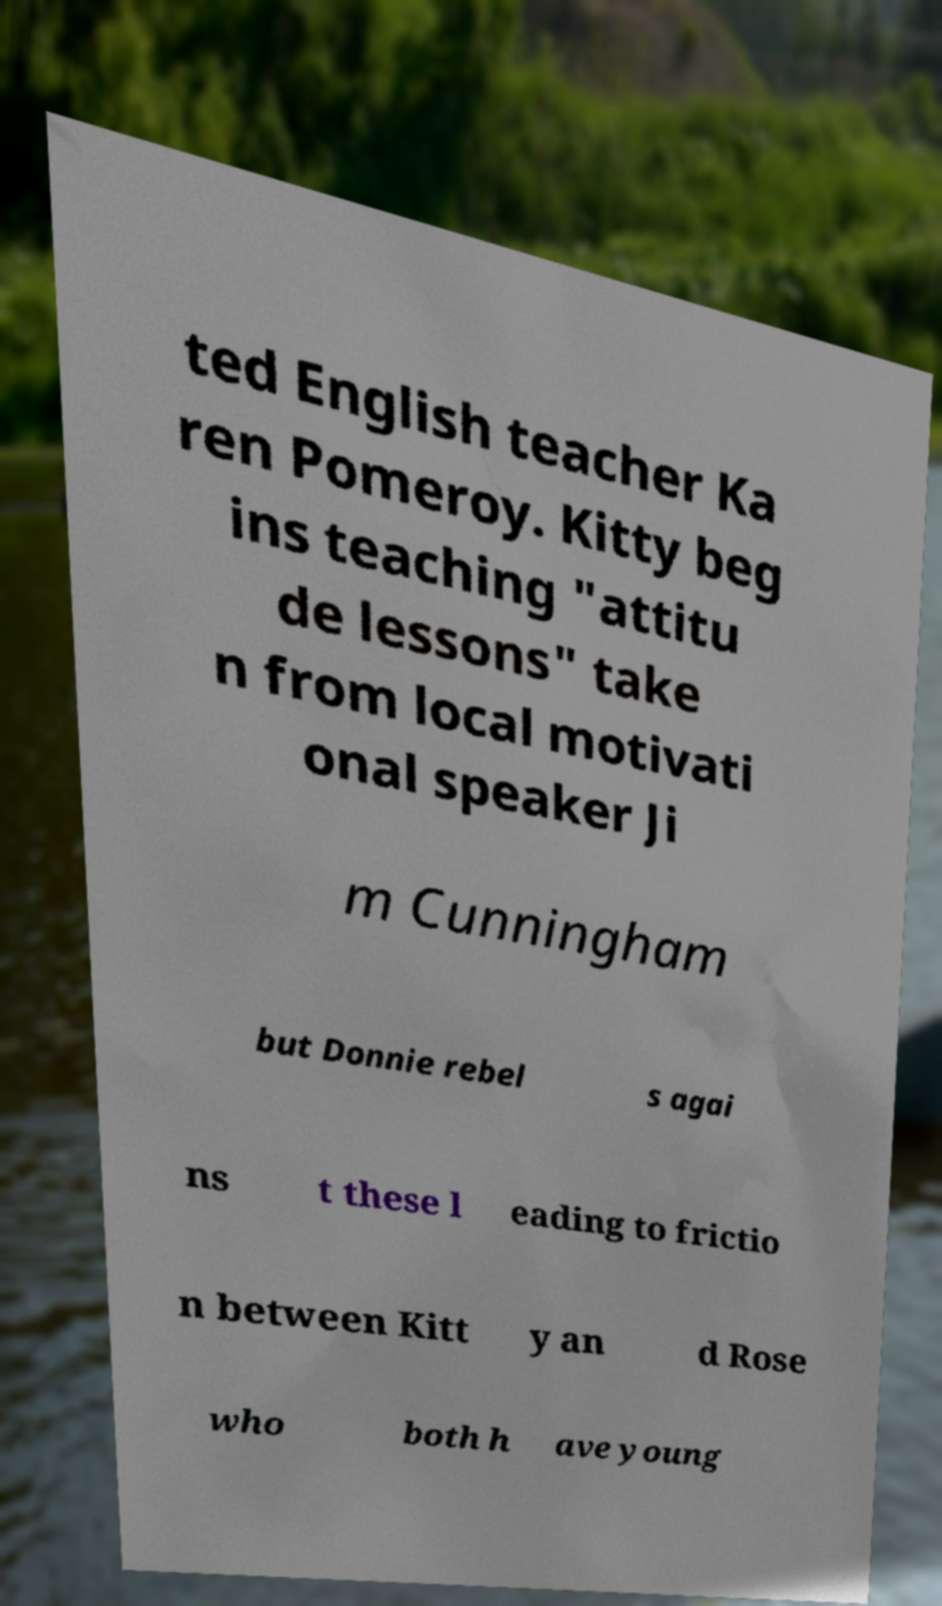Can you read and provide the text displayed in the image?This photo seems to have some interesting text. Can you extract and type it out for me? ted English teacher Ka ren Pomeroy. Kitty beg ins teaching "attitu de lessons" take n from local motivati onal speaker Ji m Cunningham but Donnie rebel s agai ns t these l eading to frictio n between Kitt y an d Rose who both h ave young 